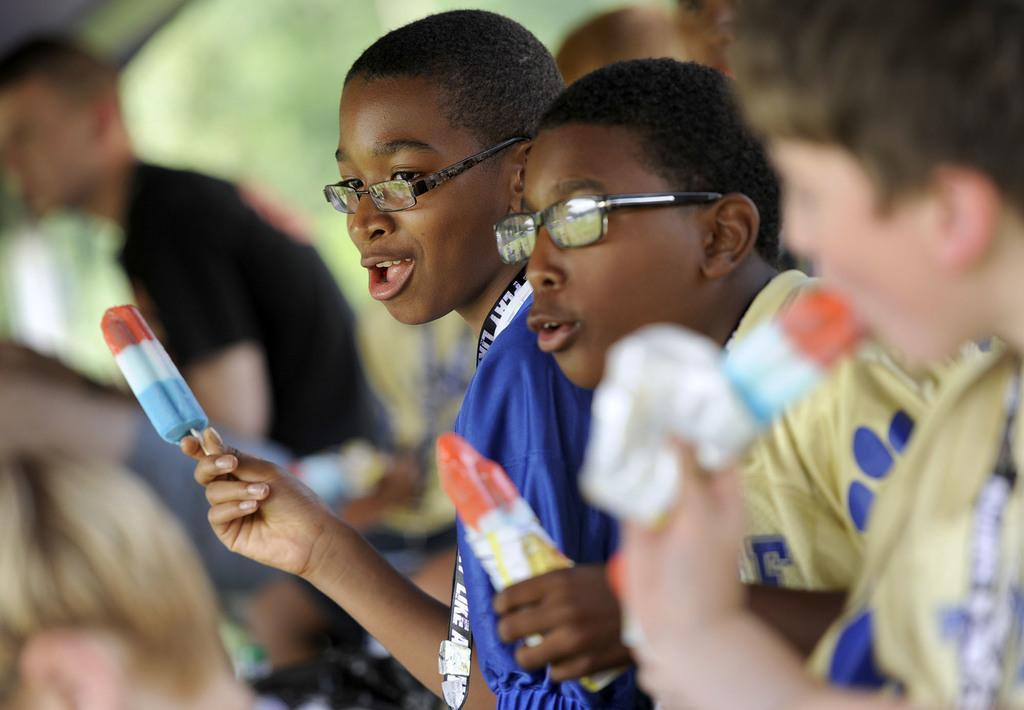Please provide a concise description of this image. In this image I can see there are few boys holding ice cream on their hand. 